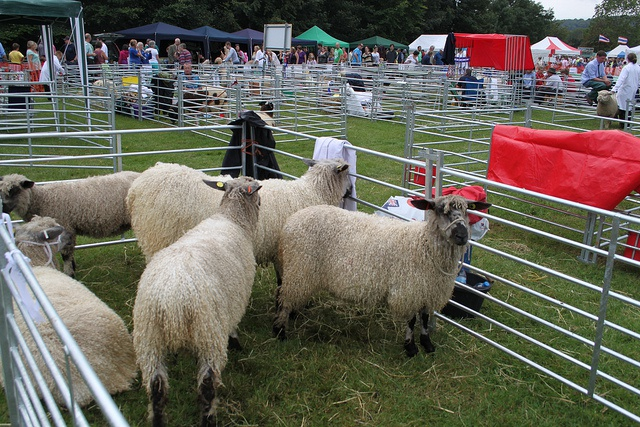Describe the objects in this image and their specific colors. I can see sheep in teal, gray, darkgray, and black tones, people in teal, black, gray, and darkgray tones, sheep in teal, darkgray, gray, and lightgray tones, sheep in teal, gray, and darkgray tones, and sheep in teal, darkgray, gray, and lightgray tones in this image. 